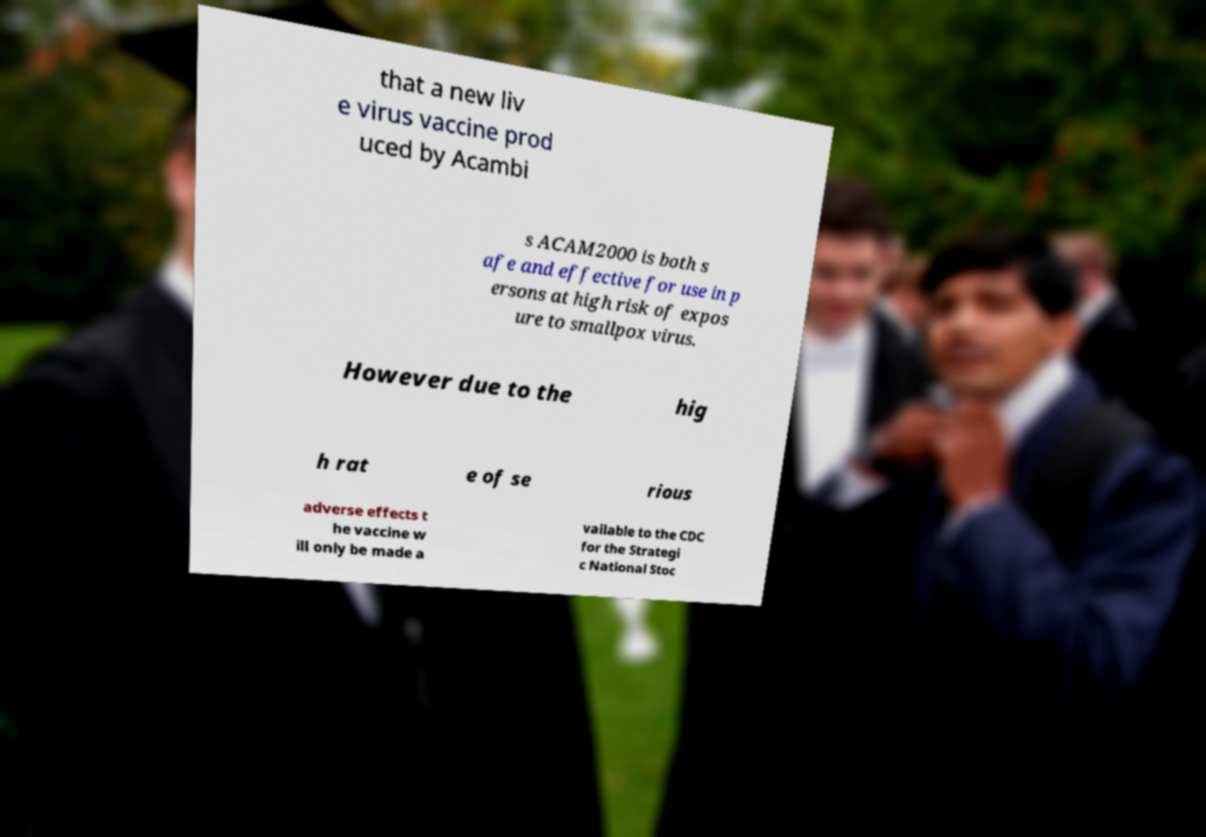Please read and relay the text visible in this image. What does it say? that a new liv e virus vaccine prod uced by Acambi s ACAM2000 is both s afe and effective for use in p ersons at high risk of expos ure to smallpox virus. However due to the hig h rat e of se rious adverse effects t he vaccine w ill only be made a vailable to the CDC for the Strategi c National Stoc 